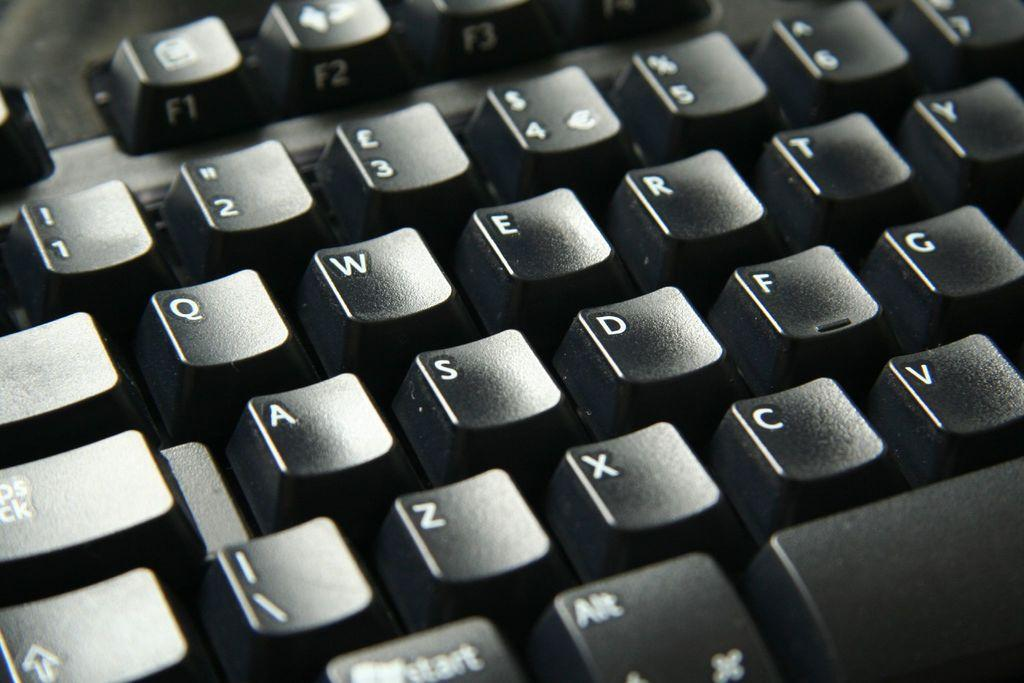<image>
Summarize the visual content of the image. The left side of a keyboard, from letters Q through T on the top, and letters Z to V on the bottom. 